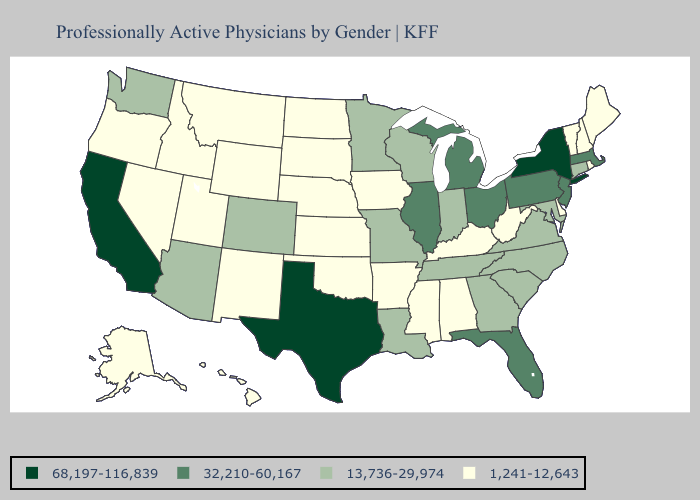Name the states that have a value in the range 32,210-60,167?
Give a very brief answer. Florida, Illinois, Massachusetts, Michigan, New Jersey, Ohio, Pennsylvania. Does Alaska have the same value as Texas?
Write a very short answer. No. Does Vermont have a lower value than Tennessee?
Write a very short answer. Yes. Among the states that border Minnesota , does Wisconsin have the lowest value?
Concise answer only. No. Does Maryland have the lowest value in the South?
Write a very short answer. No. Does the map have missing data?
Keep it brief. No. Is the legend a continuous bar?
Write a very short answer. No. Does the map have missing data?
Give a very brief answer. No. Name the states that have a value in the range 68,197-116,839?
Give a very brief answer. California, New York, Texas. What is the value of Indiana?
Write a very short answer. 13,736-29,974. Name the states that have a value in the range 1,241-12,643?
Concise answer only. Alabama, Alaska, Arkansas, Delaware, Hawaii, Idaho, Iowa, Kansas, Kentucky, Maine, Mississippi, Montana, Nebraska, Nevada, New Hampshire, New Mexico, North Dakota, Oklahoma, Oregon, Rhode Island, South Dakota, Utah, Vermont, West Virginia, Wyoming. Does Connecticut have the same value as Ohio?
Write a very short answer. No. Does the map have missing data?
Give a very brief answer. No. Among the states that border Connecticut , does Massachusetts have the highest value?
Answer briefly. No. What is the lowest value in the USA?
Keep it brief. 1,241-12,643. 